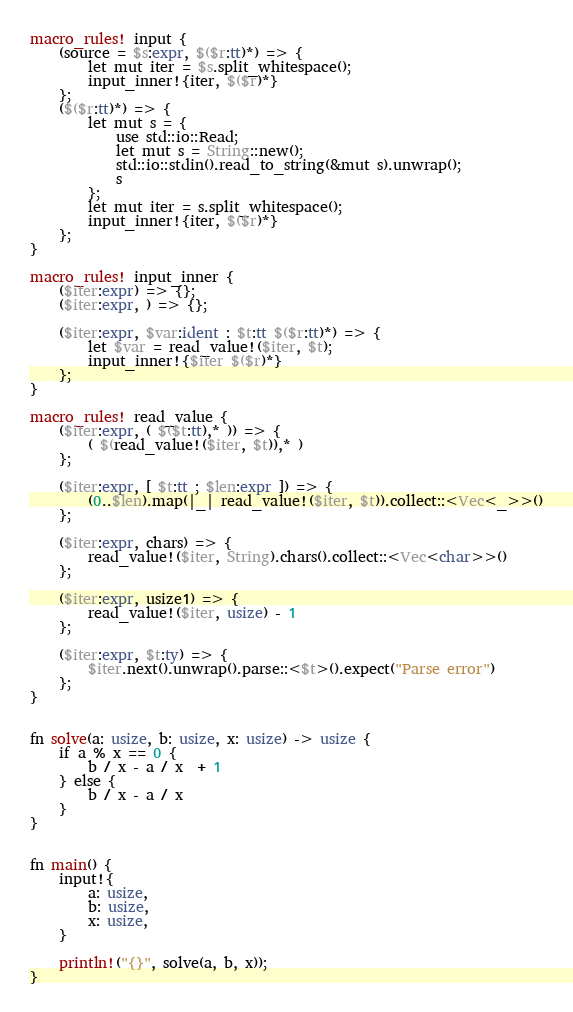<code> <loc_0><loc_0><loc_500><loc_500><_Rust_>macro_rules! input {
    (source = $s:expr, $($r:tt)*) => {
        let mut iter = $s.split_whitespace();
        input_inner!{iter, $($r)*}
    };
    ($($r:tt)*) => {
        let mut s = {
            use std::io::Read;
            let mut s = String::new();
            std::io::stdin().read_to_string(&mut s).unwrap();
            s
        };
        let mut iter = s.split_whitespace();
        input_inner!{iter, $($r)*}
    };
}

macro_rules! input_inner {
    ($iter:expr) => {};
    ($iter:expr, ) => {};

    ($iter:expr, $var:ident : $t:tt $($r:tt)*) => {
        let $var = read_value!($iter, $t);
        input_inner!{$iter $($r)*}
    };
}

macro_rules! read_value {
    ($iter:expr, ( $($t:tt),* )) => {
        ( $(read_value!($iter, $t)),* )
    };

    ($iter:expr, [ $t:tt ; $len:expr ]) => {
        (0..$len).map(|_| read_value!($iter, $t)).collect::<Vec<_>>()
    };

    ($iter:expr, chars) => {
        read_value!($iter, String).chars().collect::<Vec<char>>()
    };

    ($iter:expr, usize1) => {
        read_value!($iter, usize) - 1
    };

    ($iter:expr, $t:ty) => {
        $iter.next().unwrap().parse::<$t>().expect("Parse error")
    };
}


fn solve(a: usize, b: usize, x: usize) -> usize {
    if a % x == 0 {
        b / x - a / x  + 1
    } else {
        b / x - a / x
    }
}


fn main() {
    input!{
        a: usize,
        b: usize,
        x: usize,
    }

    println!("{}", solve(a, b, x));
}


</code> 